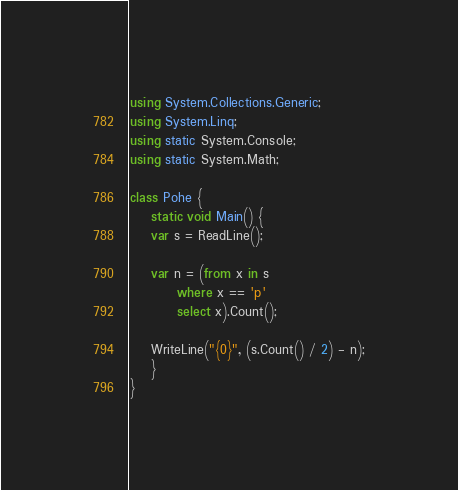<code> <loc_0><loc_0><loc_500><loc_500><_C#_>using System.Collections.Generic;
using System.Linq;
using static System.Console;
using static System.Math;

class Pohe {
    static void Main() {
	var s = ReadLine();

	var n = (from x in s
		 where x == 'p'
		 select x).Count();

	WriteLine("{0}", (s.Count() / 2) - n);
    }
}
</code> 